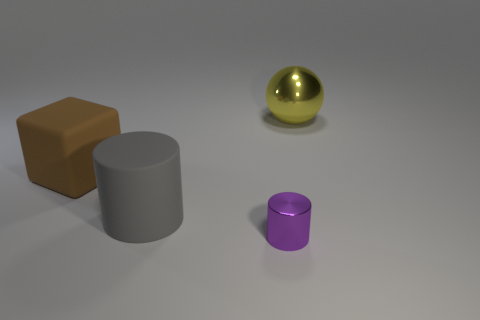Add 2 tiny red matte objects. How many objects exist? 6 Subtract 1 cubes. How many cubes are left? 0 Subtract all purple cylinders. How many cylinders are left? 1 Subtract all balls. How many objects are left? 3 Subtract all yellow cylinders. Subtract all red spheres. How many cylinders are left? 2 Subtract all blocks. Subtract all purple metallic cubes. How many objects are left? 3 Add 1 big metallic balls. How many big metallic balls are left? 2 Add 4 metallic spheres. How many metallic spheres exist? 5 Subtract 1 gray cylinders. How many objects are left? 3 